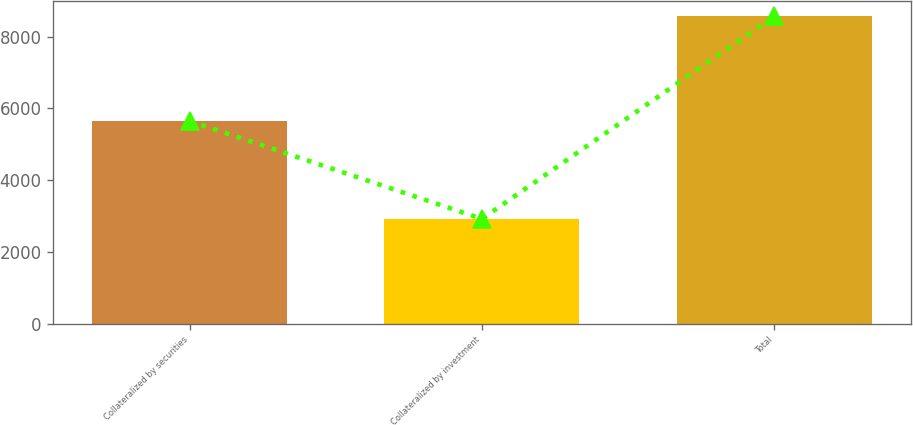Convert chart to OTSL. <chart><loc_0><loc_0><loc_500><loc_500><bar_chart><fcel>Collateralized by securities<fcel>Collateralized by investment<fcel>Total<nl><fcel>5651<fcel>2921<fcel>8572<nl></chart> 